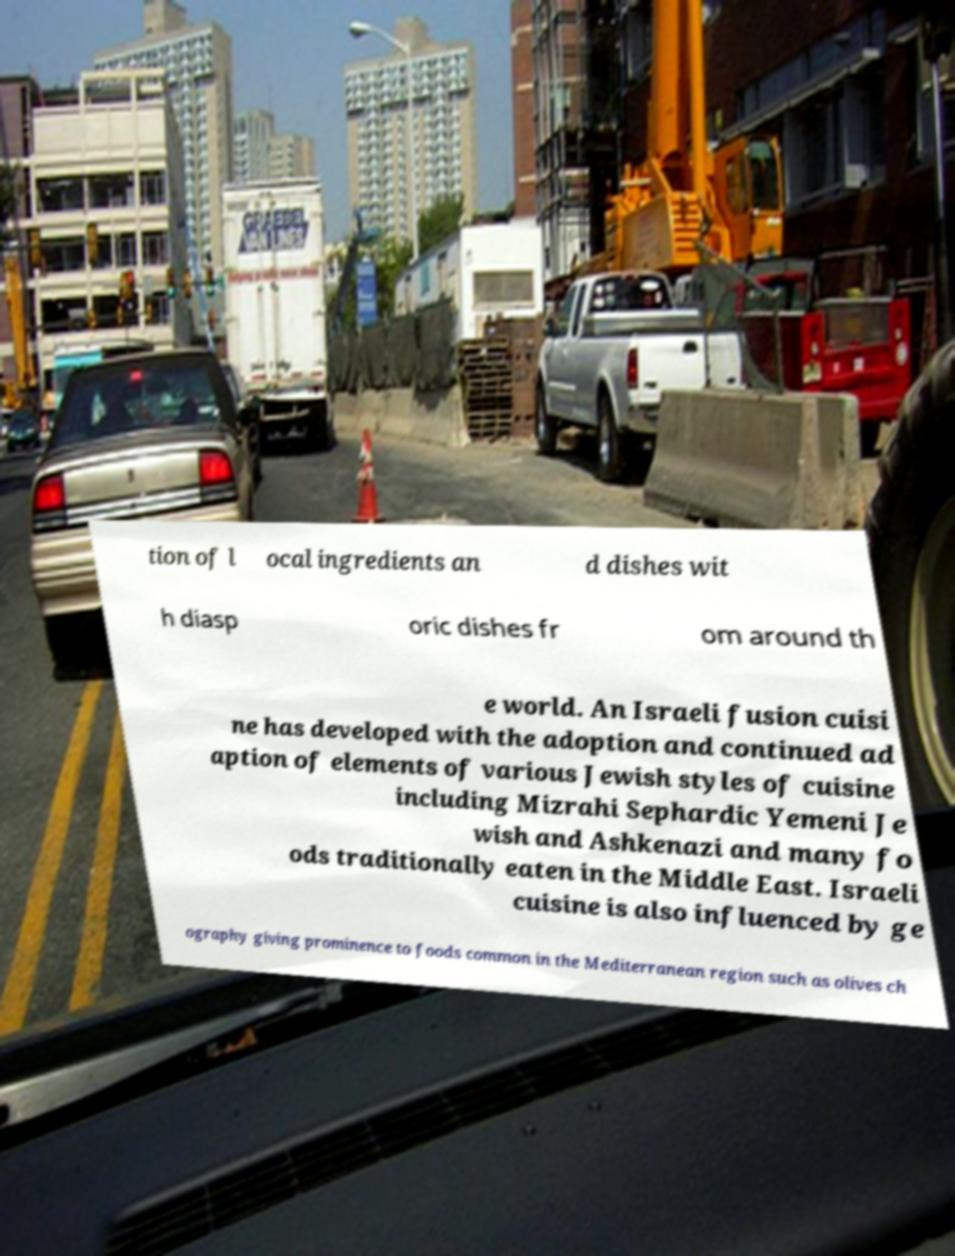For documentation purposes, I need the text within this image transcribed. Could you provide that? tion of l ocal ingredients an d dishes wit h diasp oric dishes fr om around th e world. An Israeli fusion cuisi ne has developed with the adoption and continued ad aption of elements of various Jewish styles of cuisine including Mizrahi Sephardic Yemeni Je wish and Ashkenazi and many fo ods traditionally eaten in the Middle East. Israeli cuisine is also influenced by ge ography giving prominence to foods common in the Mediterranean region such as olives ch 